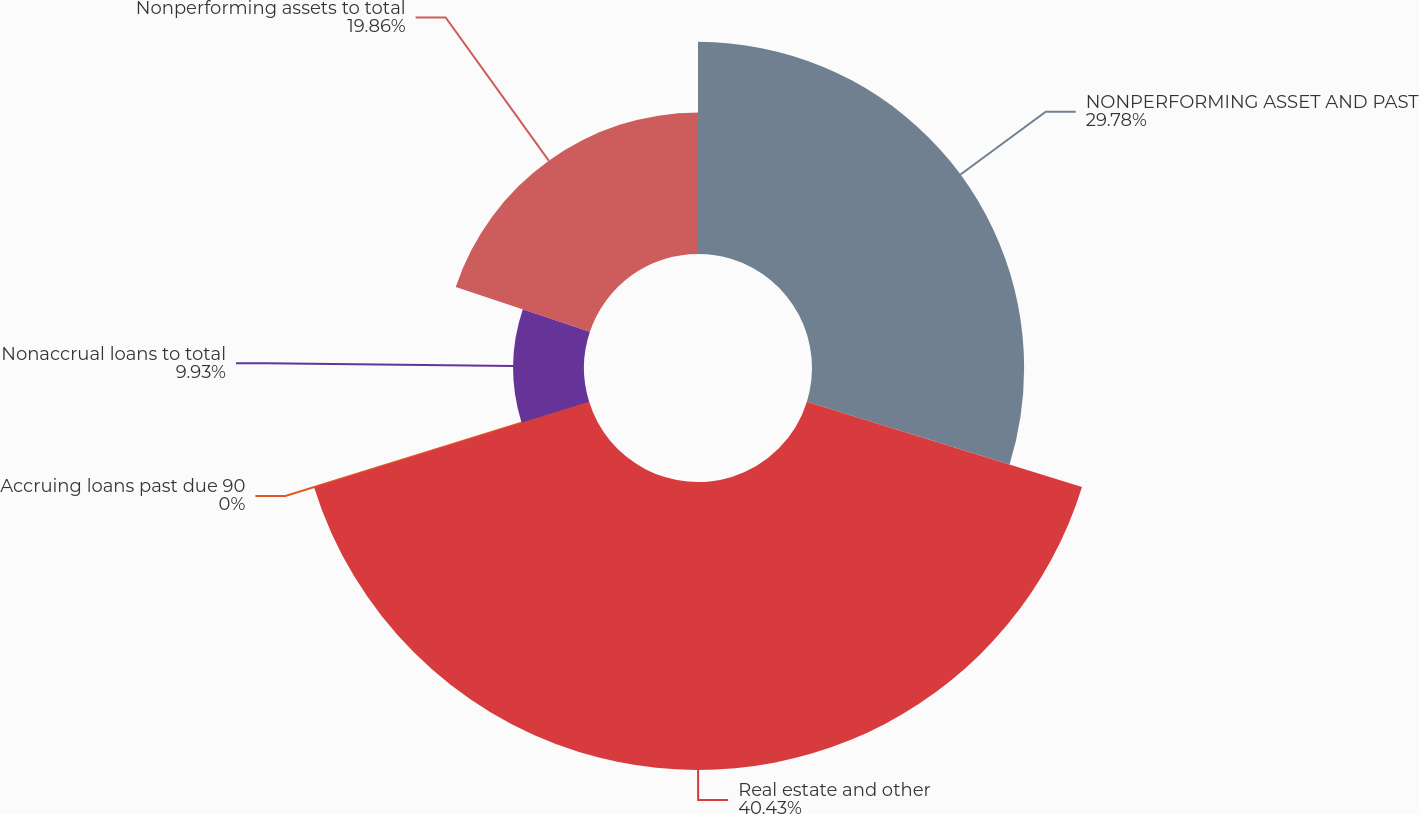Convert chart. <chart><loc_0><loc_0><loc_500><loc_500><pie_chart><fcel>NONPERFORMING ASSET AND PAST<fcel>Real estate and other<fcel>Accruing loans past due 90<fcel>Nonaccrual loans to total<fcel>Nonperforming assets to total<nl><fcel>29.78%<fcel>40.43%<fcel>0.0%<fcel>9.93%<fcel>19.86%<nl></chart> 